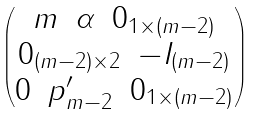<formula> <loc_0><loc_0><loc_500><loc_500>\begin{pmatrix} \begin{matrix} m & \alpha & 0 _ { 1 \times ( m - 2 ) } \end{matrix} \\ \begin{matrix} 0 _ { ( m - 2 ) \times 2 } & - I _ { ( m - 2 ) } \end{matrix} \\ \begin{matrix} 0 & p ^ { \prime } _ { m - 2 } & 0 _ { 1 \times ( m - 2 ) } \end{matrix} \\ \end{pmatrix}</formula> 